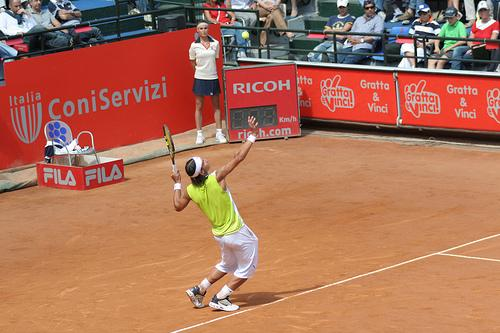Which hand caused the ball to go aloft here? Please explain your reasoning. server's right. A tennis player is holding a racket in one hand. he uses this hand to hit the ball and the other to throw. 